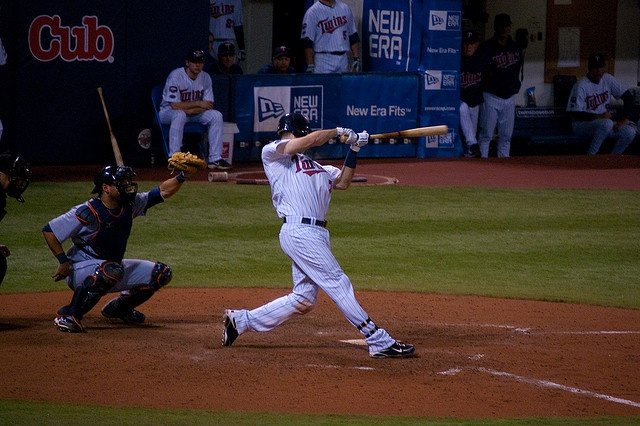Describe the objects in this image and their specific colors. I can see people in black, darkgray, gray, and purple tones, people in black, blue, maroon, and navy tones, people in black, navy, and darkblue tones, people in black, blue, purple, and navy tones, and people in black, navy, and darkblue tones in this image. 